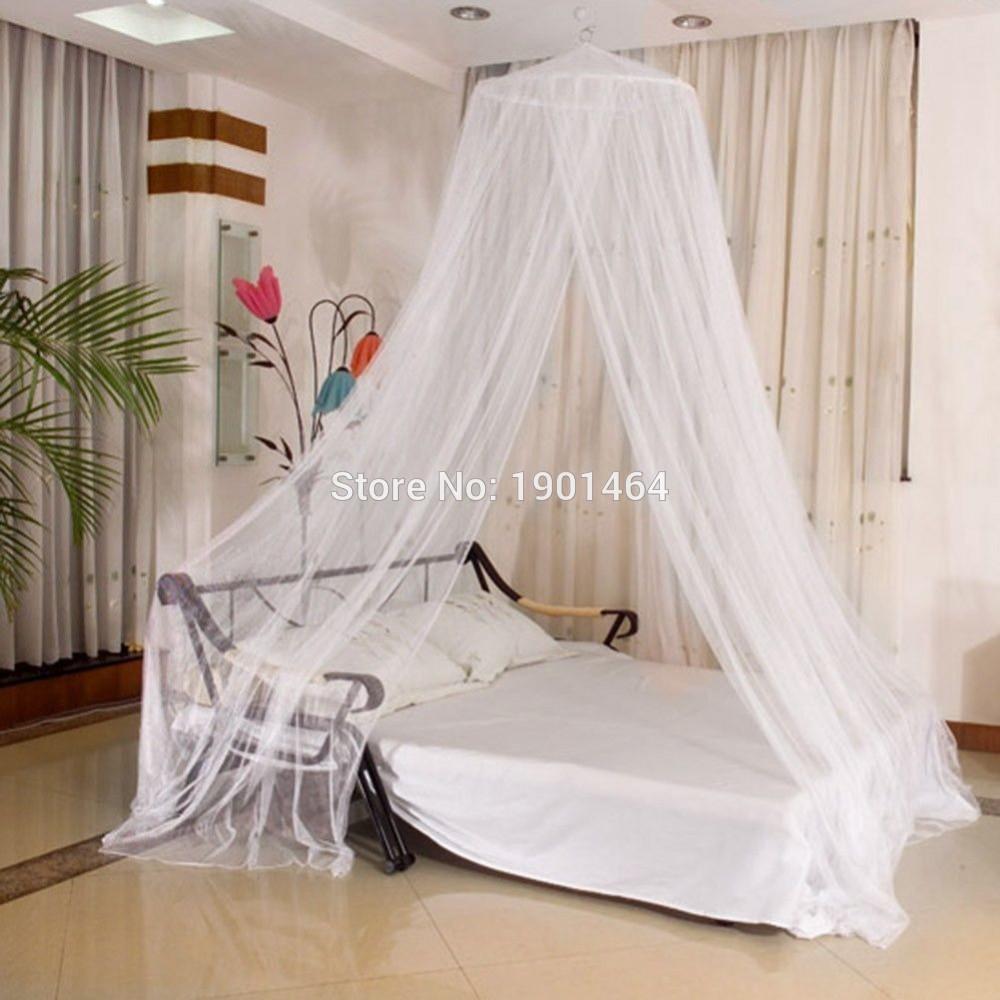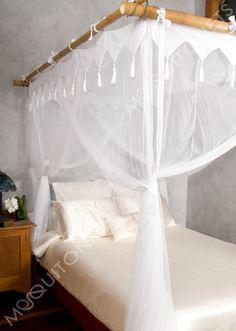The first image is the image on the left, the second image is the image on the right. Examine the images to the left and right. Is the description "One bed has a rectangular canopy that ties at each corner, like a drape." accurate? Answer yes or no. Yes. 